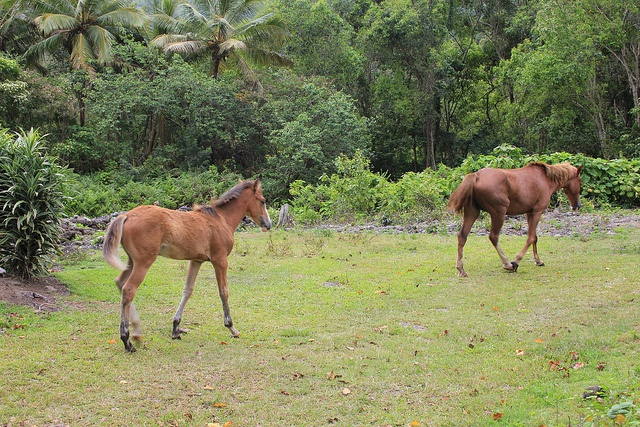Describe the objects in this image and their specific colors. I can see horse in gray, brown, and tan tones and horse in gray, brown, maroon, and black tones in this image. 